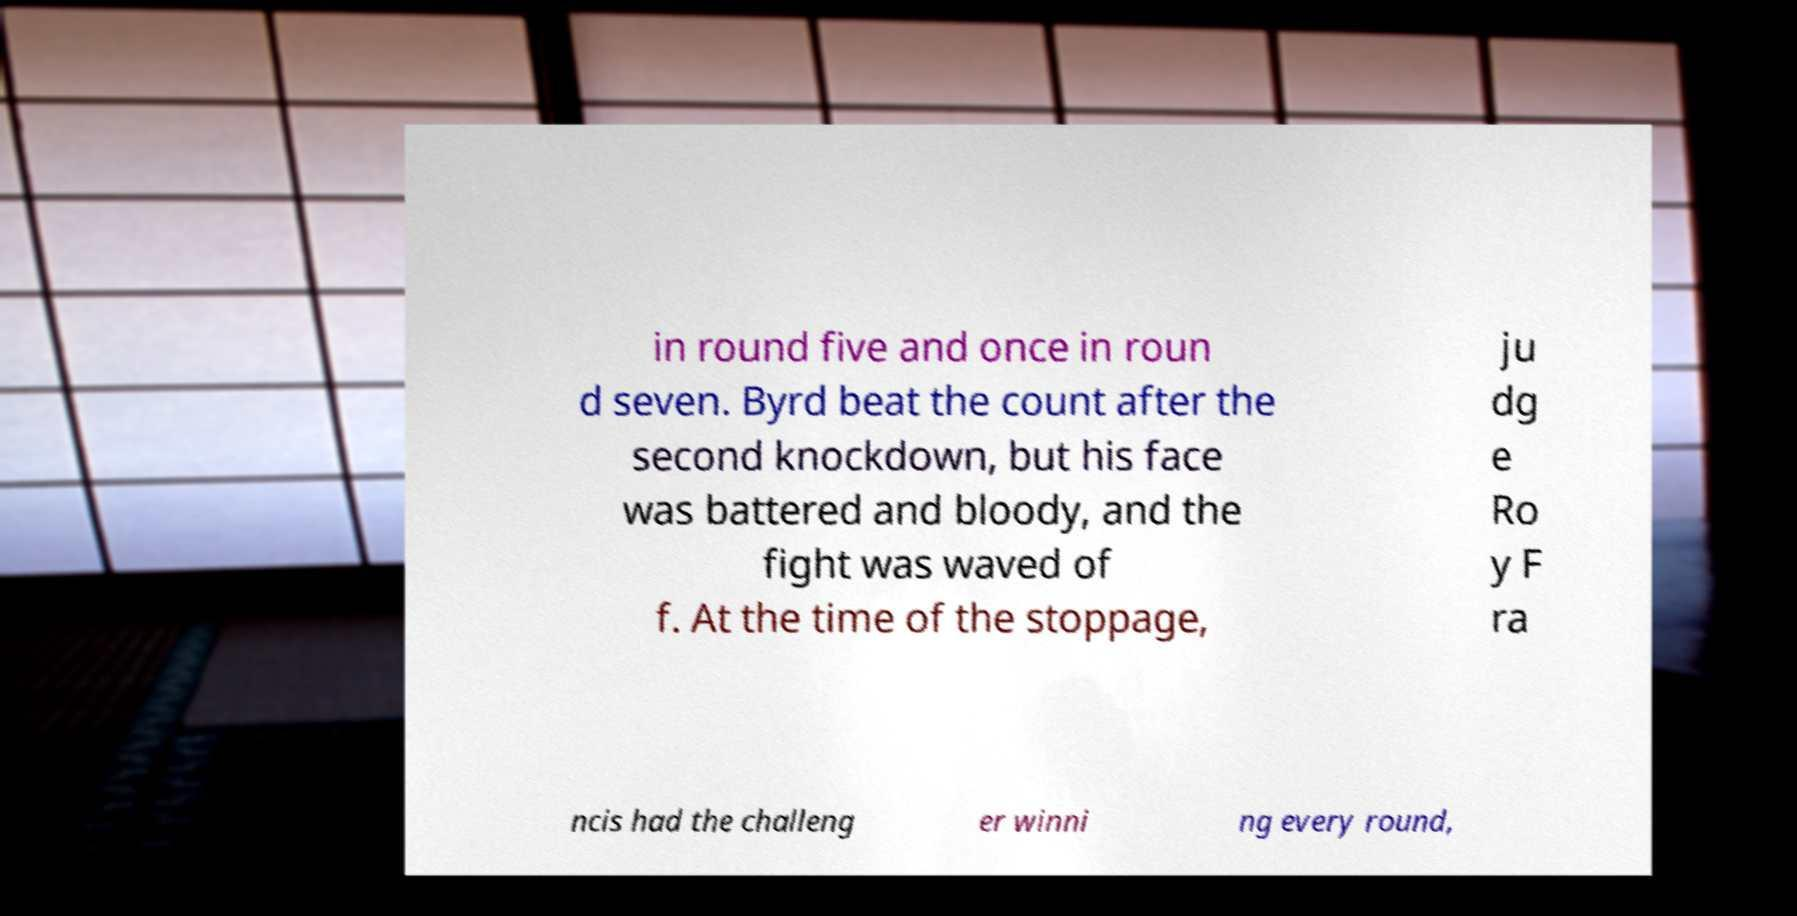There's text embedded in this image that I need extracted. Can you transcribe it verbatim? in round five and once in roun d seven. Byrd beat the count after the second knockdown, but his face was battered and bloody, and the fight was waved of f. At the time of the stoppage, ju dg e Ro y F ra ncis had the challeng er winni ng every round, 